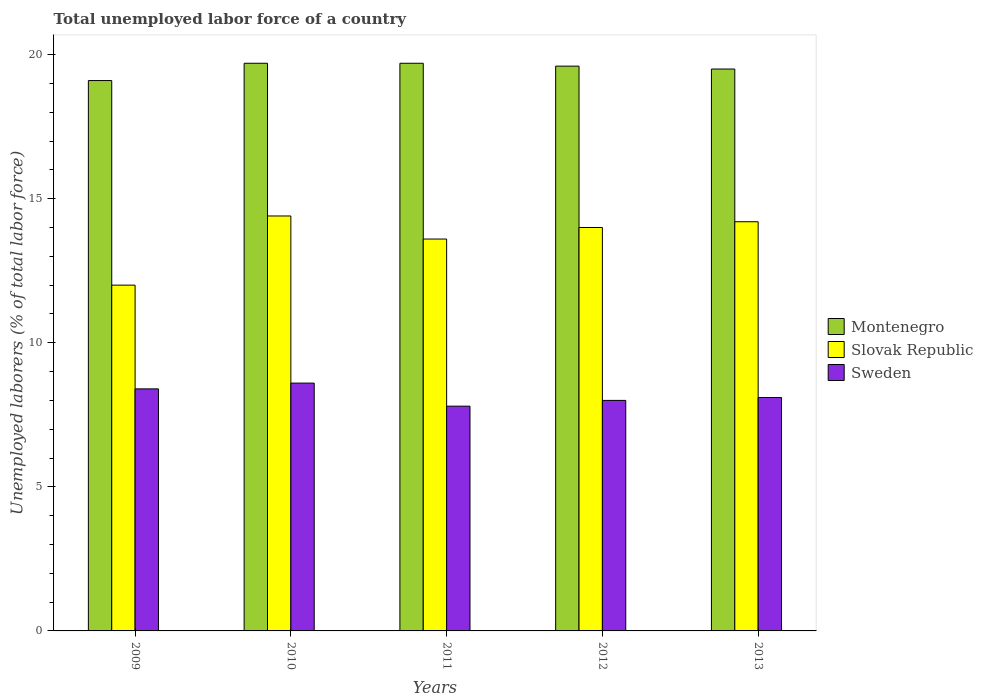How many different coloured bars are there?
Your response must be concise. 3. Are the number of bars per tick equal to the number of legend labels?
Your answer should be very brief. Yes. How many bars are there on the 3rd tick from the left?
Your response must be concise. 3. What is the label of the 2nd group of bars from the left?
Offer a terse response. 2010. In how many cases, is the number of bars for a given year not equal to the number of legend labels?
Make the answer very short. 0. What is the total unemployed labor force in Slovak Republic in 2011?
Your answer should be compact. 13.6. Across all years, what is the maximum total unemployed labor force in Montenegro?
Give a very brief answer. 19.7. Across all years, what is the minimum total unemployed labor force in Sweden?
Your answer should be very brief. 7.8. In which year was the total unemployed labor force in Sweden maximum?
Your response must be concise. 2010. In which year was the total unemployed labor force in Sweden minimum?
Provide a succinct answer. 2011. What is the total total unemployed labor force in Montenegro in the graph?
Keep it short and to the point. 97.6. What is the difference between the total unemployed labor force in Slovak Republic in 2011 and that in 2012?
Provide a short and direct response. -0.4. What is the difference between the total unemployed labor force in Slovak Republic in 2011 and the total unemployed labor force in Montenegro in 2009?
Give a very brief answer. -5.5. What is the average total unemployed labor force in Sweden per year?
Keep it short and to the point. 8.18. In the year 2011, what is the difference between the total unemployed labor force in Sweden and total unemployed labor force in Slovak Republic?
Your answer should be compact. -5.8. What is the ratio of the total unemployed labor force in Montenegro in 2009 to that in 2011?
Make the answer very short. 0.97. Is the total unemployed labor force in Slovak Republic in 2009 less than that in 2012?
Offer a terse response. Yes. Is the difference between the total unemployed labor force in Sweden in 2010 and 2012 greater than the difference between the total unemployed labor force in Slovak Republic in 2010 and 2012?
Provide a short and direct response. Yes. What is the difference between the highest and the second highest total unemployed labor force in Sweden?
Provide a short and direct response. 0.2. What is the difference between the highest and the lowest total unemployed labor force in Montenegro?
Provide a short and direct response. 0.6. What does the 2nd bar from the left in 2013 represents?
Provide a succinct answer. Slovak Republic. How many bars are there?
Offer a very short reply. 15. How many years are there in the graph?
Give a very brief answer. 5. What is the difference between two consecutive major ticks on the Y-axis?
Your answer should be very brief. 5. Are the values on the major ticks of Y-axis written in scientific E-notation?
Provide a succinct answer. No. Does the graph contain any zero values?
Ensure brevity in your answer.  No. Does the graph contain grids?
Make the answer very short. No. Where does the legend appear in the graph?
Make the answer very short. Center right. How many legend labels are there?
Your answer should be compact. 3. What is the title of the graph?
Provide a succinct answer. Total unemployed labor force of a country. What is the label or title of the Y-axis?
Provide a short and direct response. Unemployed laborers (% of total labor force). What is the Unemployed laborers (% of total labor force) in Montenegro in 2009?
Offer a very short reply. 19.1. What is the Unemployed laborers (% of total labor force) in Sweden in 2009?
Your response must be concise. 8.4. What is the Unemployed laborers (% of total labor force) of Montenegro in 2010?
Provide a succinct answer. 19.7. What is the Unemployed laborers (% of total labor force) of Slovak Republic in 2010?
Provide a succinct answer. 14.4. What is the Unemployed laborers (% of total labor force) of Sweden in 2010?
Give a very brief answer. 8.6. What is the Unemployed laborers (% of total labor force) in Montenegro in 2011?
Make the answer very short. 19.7. What is the Unemployed laborers (% of total labor force) in Slovak Republic in 2011?
Make the answer very short. 13.6. What is the Unemployed laborers (% of total labor force) of Sweden in 2011?
Keep it short and to the point. 7.8. What is the Unemployed laborers (% of total labor force) in Montenegro in 2012?
Your answer should be compact. 19.6. What is the Unemployed laborers (% of total labor force) of Slovak Republic in 2013?
Provide a succinct answer. 14.2. What is the Unemployed laborers (% of total labor force) in Sweden in 2013?
Your answer should be compact. 8.1. Across all years, what is the maximum Unemployed laborers (% of total labor force) in Montenegro?
Ensure brevity in your answer.  19.7. Across all years, what is the maximum Unemployed laborers (% of total labor force) of Slovak Republic?
Make the answer very short. 14.4. Across all years, what is the maximum Unemployed laborers (% of total labor force) of Sweden?
Keep it short and to the point. 8.6. Across all years, what is the minimum Unemployed laborers (% of total labor force) of Montenegro?
Offer a very short reply. 19.1. Across all years, what is the minimum Unemployed laborers (% of total labor force) of Slovak Republic?
Offer a very short reply. 12. Across all years, what is the minimum Unemployed laborers (% of total labor force) in Sweden?
Offer a terse response. 7.8. What is the total Unemployed laborers (% of total labor force) in Montenegro in the graph?
Your response must be concise. 97.6. What is the total Unemployed laborers (% of total labor force) in Slovak Republic in the graph?
Offer a terse response. 68.2. What is the total Unemployed laborers (% of total labor force) of Sweden in the graph?
Provide a short and direct response. 40.9. What is the difference between the Unemployed laborers (% of total labor force) of Montenegro in 2009 and that in 2010?
Offer a very short reply. -0.6. What is the difference between the Unemployed laborers (% of total labor force) in Slovak Republic in 2009 and that in 2010?
Provide a short and direct response. -2.4. What is the difference between the Unemployed laborers (% of total labor force) of Sweden in 2009 and that in 2010?
Your response must be concise. -0.2. What is the difference between the Unemployed laborers (% of total labor force) in Montenegro in 2009 and that in 2011?
Offer a terse response. -0.6. What is the difference between the Unemployed laborers (% of total labor force) in Slovak Republic in 2009 and that in 2011?
Make the answer very short. -1.6. What is the difference between the Unemployed laborers (% of total labor force) in Sweden in 2009 and that in 2011?
Offer a very short reply. 0.6. What is the difference between the Unemployed laborers (% of total labor force) of Montenegro in 2009 and that in 2012?
Provide a succinct answer. -0.5. What is the difference between the Unemployed laborers (% of total labor force) in Montenegro in 2009 and that in 2013?
Provide a short and direct response. -0.4. What is the difference between the Unemployed laborers (% of total labor force) in Sweden in 2009 and that in 2013?
Keep it short and to the point. 0.3. What is the difference between the Unemployed laborers (% of total labor force) in Montenegro in 2010 and that in 2011?
Give a very brief answer. 0. What is the difference between the Unemployed laborers (% of total labor force) of Slovak Republic in 2010 and that in 2011?
Keep it short and to the point. 0.8. What is the difference between the Unemployed laborers (% of total labor force) in Sweden in 2010 and that in 2011?
Provide a short and direct response. 0.8. What is the difference between the Unemployed laborers (% of total labor force) of Montenegro in 2010 and that in 2012?
Your answer should be compact. 0.1. What is the difference between the Unemployed laborers (% of total labor force) of Sweden in 2010 and that in 2012?
Keep it short and to the point. 0.6. What is the difference between the Unemployed laborers (% of total labor force) in Montenegro in 2010 and that in 2013?
Offer a terse response. 0.2. What is the difference between the Unemployed laborers (% of total labor force) in Sweden in 2010 and that in 2013?
Your answer should be very brief. 0.5. What is the difference between the Unemployed laborers (% of total labor force) in Montenegro in 2011 and that in 2012?
Offer a very short reply. 0.1. What is the difference between the Unemployed laborers (% of total labor force) of Slovak Republic in 2011 and that in 2012?
Give a very brief answer. -0.4. What is the difference between the Unemployed laborers (% of total labor force) of Montenegro in 2011 and that in 2013?
Your answer should be very brief. 0.2. What is the difference between the Unemployed laborers (% of total labor force) of Sweden in 2011 and that in 2013?
Keep it short and to the point. -0.3. What is the difference between the Unemployed laborers (% of total labor force) of Montenegro in 2012 and that in 2013?
Make the answer very short. 0.1. What is the difference between the Unemployed laborers (% of total labor force) in Slovak Republic in 2012 and that in 2013?
Your answer should be very brief. -0.2. What is the difference between the Unemployed laborers (% of total labor force) of Montenegro in 2009 and the Unemployed laborers (% of total labor force) of Slovak Republic in 2010?
Ensure brevity in your answer.  4.7. What is the difference between the Unemployed laborers (% of total labor force) of Montenegro in 2009 and the Unemployed laborers (% of total labor force) of Sweden in 2011?
Provide a short and direct response. 11.3. What is the difference between the Unemployed laborers (% of total labor force) in Slovak Republic in 2009 and the Unemployed laborers (% of total labor force) in Sweden in 2011?
Your answer should be very brief. 4.2. What is the difference between the Unemployed laborers (% of total labor force) in Montenegro in 2009 and the Unemployed laborers (% of total labor force) in Slovak Republic in 2013?
Keep it short and to the point. 4.9. What is the difference between the Unemployed laborers (% of total labor force) in Montenegro in 2009 and the Unemployed laborers (% of total labor force) in Sweden in 2013?
Offer a very short reply. 11. What is the difference between the Unemployed laborers (% of total labor force) of Slovak Republic in 2009 and the Unemployed laborers (% of total labor force) of Sweden in 2013?
Offer a terse response. 3.9. What is the difference between the Unemployed laborers (% of total labor force) in Slovak Republic in 2010 and the Unemployed laborers (% of total labor force) in Sweden in 2011?
Give a very brief answer. 6.6. What is the difference between the Unemployed laborers (% of total labor force) in Montenegro in 2010 and the Unemployed laborers (% of total labor force) in Slovak Republic in 2012?
Keep it short and to the point. 5.7. What is the difference between the Unemployed laborers (% of total labor force) of Montenegro in 2010 and the Unemployed laborers (% of total labor force) of Sweden in 2012?
Your answer should be very brief. 11.7. What is the difference between the Unemployed laborers (% of total labor force) in Slovak Republic in 2010 and the Unemployed laborers (% of total labor force) in Sweden in 2012?
Your answer should be very brief. 6.4. What is the difference between the Unemployed laborers (% of total labor force) in Montenegro in 2010 and the Unemployed laborers (% of total labor force) in Sweden in 2013?
Your response must be concise. 11.6. What is the difference between the Unemployed laborers (% of total labor force) in Slovak Republic in 2010 and the Unemployed laborers (% of total labor force) in Sweden in 2013?
Offer a very short reply. 6.3. What is the difference between the Unemployed laborers (% of total labor force) of Montenegro in 2011 and the Unemployed laborers (% of total labor force) of Sweden in 2012?
Provide a succinct answer. 11.7. What is the difference between the Unemployed laborers (% of total labor force) in Montenegro in 2012 and the Unemployed laborers (% of total labor force) in Slovak Republic in 2013?
Your answer should be compact. 5.4. What is the difference between the Unemployed laborers (% of total labor force) of Montenegro in 2012 and the Unemployed laborers (% of total labor force) of Sweden in 2013?
Your response must be concise. 11.5. What is the average Unemployed laborers (% of total labor force) of Montenegro per year?
Ensure brevity in your answer.  19.52. What is the average Unemployed laborers (% of total labor force) in Slovak Republic per year?
Offer a terse response. 13.64. What is the average Unemployed laborers (% of total labor force) in Sweden per year?
Provide a short and direct response. 8.18. In the year 2009, what is the difference between the Unemployed laborers (% of total labor force) of Montenegro and Unemployed laborers (% of total labor force) of Slovak Republic?
Keep it short and to the point. 7.1. In the year 2009, what is the difference between the Unemployed laborers (% of total labor force) in Slovak Republic and Unemployed laborers (% of total labor force) in Sweden?
Offer a terse response. 3.6. In the year 2010, what is the difference between the Unemployed laborers (% of total labor force) of Montenegro and Unemployed laborers (% of total labor force) of Slovak Republic?
Keep it short and to the point. 5.3. In the year 2013, what is the difference between the Unemployed laborers (% of total labor force) of Montenegro and Unemployed laborers (% of total labor force) of Sweden?
Provide a succinct answer. 11.4. What is the ratio of the Unemployed laborers (% of total labor force) of Montenegro in 2009 to that in 2010?
Provide a succinct answer. 0.97. What is the ratio of the Unemployed laborers (% of total labor force) in Slovak Republic in 2009 to that in 2010?
Your answer should be very brief. 0.83. What is the ratio of the Unemployed laborers (% of total labor force) in Sweden in 2009 to that in 2010?
Provide a short and direct response. 0.98. What is the ratio of the Unemployed laborers (% of total labor force) of Montenegro in 2009 to that in 2011?
Your answer should be very brief. 0.97. What is the ratio of the Unemployed laborers (% of total labor force) in Slovak Republic in 2009 to that in 2011?
Offer a very short reply. 0.88. What is the ratio of the Unemployed laborers (% of total labor force) of Montenegro in 2009 to that in 2012?
Your response must be concise. 0.97. What is the ratio of the Unemployed laborers (% of total labor force) in Sweden in 2009 to that in 2012?
Keep it short and to the point. 1.05. What is the ratio of the Unemployed laborers (% of total labor force) of Montenegro in 2009 to that in 2013?
Your answer should be compact. 0.98. What is the ratio of the Unemployed laborers (% of total labor force) of Slovak Republic in 2009 to that in 2013?
Offer a terse response. 0.85. What is the ratio of the Unemployed laborers (% of total labor force) of Slovak Republic in 2010 to that in 2011?
Your response must be concise. 1.06. What is the ratio of the Unemployed laborers (% of total labor force) of Sweden in 2010 to that in 2011?
Provide a short and direct response. 1.1. What is the ratio of the Unemployed laborers (% of total labor force) of Montenegro in 2010 to that in 2012?
Give a very brief answer. 1.01. What is the ratio of the Unemployed laborers (% of total labor force) of Slovak Republic in 2010 to that in 2012?
Offer a very short reply. 1.03. What is the ratio of the Unemployed laborers (% of total labor force) in Sweden in 2010 to that in 2012?
Give a very brief answer. 1.07. What is the ratio of the Unemployed laborers (% of total labor force) of Montenegro in 2010 to that in 2013?
Offer a terse response. 1.01. What is the ratio of the Unemployed laborers (% of total labor force) of Slovak Republic in 2010 to that in 2013?
Your answer should be compact. 1.01. What is the ratio of the Unemployed laborers (% of total labor force) in Sweden in 2010 to that in 2013?
Make the answer very short. 1.06. What is the ratio of the Unemployed laborers (% of total labor force) in Slovak Republic in 2011 to that in 2012?
Your answer should be very brief. 0.97. What is the ratio of the Unemployed laborers (% of total labor force) in Sweden in 2011 to that in 2012?
Give a very brief answer. 0.97. What is the ratio of the Unemployed laborers (% of total labor force) in Montenegro in 2011 to that in 2013?
Your answer should be compact. 1.01. What is the ratio of the Unemployed laborers (% of total labor force) of Slovak Republic in 2011 to that in 2013?
Provide a short and direct response. 0.96. What is the ratio of the Unemployed laborers (% of total labor force) in Sweden in 2011 to that in 2013?
Your answer should be compact. 0.96. What is the ratio of the Unemployed laborers (% of total labor force) of Montenegro in 2012 to that in 2013?
Give a very brief answer. 1.01. What is the ratio of the Unemployed laborers (% of total labor force) in Slovak Republic in 2012 to that in 2013?
Offer a terse response. 0.99. What is the ratio of the Unemployed laborers (% of total labor force) of Sweden in 2012 to that in 2013?
Provide a short and direct response. 0.99. 